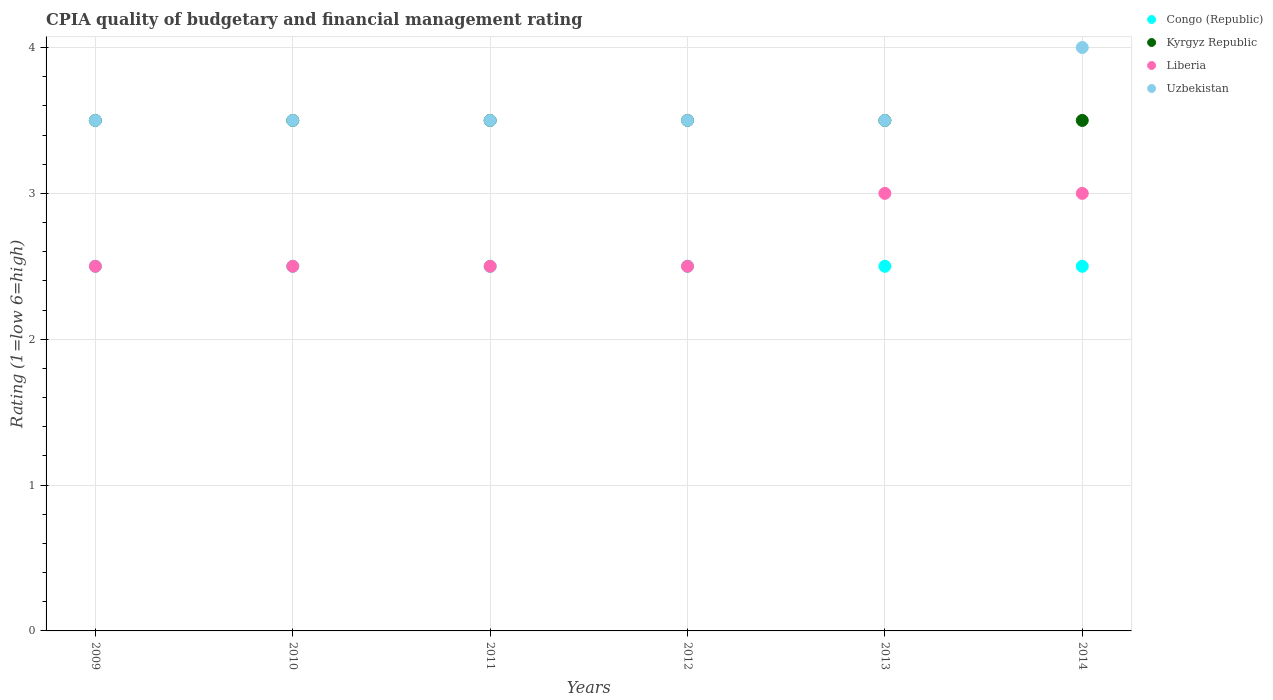In which year was the CPIA rating in Liberia minimum?
Give a very brief answer. 2009. What is the total CPIA rating in Kyrgyz Republic in the graph?
Your answer should be very brief. 21. What is the difference between the CPIA rating in Liberia in 2010 and the CPIA rating in Kyrgyz Republic in 2009?
Provide a short and direct response. -1. Is the CPIA rating in Kyrgyz Republic in 2012 less than that in 2013?
Give a very brief answer. No. Is the difference between the CPIA rating in Congo (Republic) in 2013 and 2014 greater than the difference between the CPIA rating in Kyrgyz Republic in 2013 and 2014?
Your response must be concise. No. What is the difference between the highest and the lowest CPIA rating in Kyrgyz Republic?
Provide a short and direct response. 0. In how many years, is the CPIA rating in Liberia greater than the average CPIA rating in Liberia taken over all years?
Ensure brevity in your answer.  2. Is the sum of the CPIA rating in Congo (Republic) in 2009 and 2011 greater than the maximum CPIA rating in Kyrgyz Republic across all years?
Offer a very short reply. Yes. Is it the case that in every year, the sum of the CPIA rating in Congo (Republic) and CPIA rating in Uzbekistan  is greater than the sum of CPIA rating in Kyrgyz Republic and CPIA rating in Liberia?
Provide a short and direct response. No. Does the CPIA rating in Uzbekistan monotonically increase over the years?
Your answer should be compact. No. Is the CPIA rating in Uzbekistan strictly less than the CPIA rating in Congo (Republic) over the years?
Make the answer very short. No. What is the difference between two consecutive major ticks on the Y-axis?
Give a very brief answer. 1. Are the values on the major ticks of Y-axis written in scientific E-notation?
Offer a very short reply. No. Does the graph contain any zero values?
Offer a very short reply. No. How many legend labels are there?
Make the answer very short. 4. What is the title of the graph?
Your answer should be very brief. CPIA quality of budgetary and financial management rating. Does "West Bank and Gaza" appear as one of the legend labels in the graph?
Provide a succinct answer. No. What is the Rating (1=low 6=high) in Congo (Republic) in 2009?
Make the answer very short. 2.5. What is the Rating (1=low 6=high) in Kyrgyz Republic in 2010?
Give a very brief answer. 3.5. What is the Rating (1=low 6=high) of Uzbekistan in 2010?
Provide a short and direct response. 3.5. What is the Rating (1=low 6=high) of Congo (Republic) in 2011?
Provide a short and direct response. 2.5. What is the Rating (1=low 6=high) in Kyrgyz Republic in 2011?
Give a very brief answer. 3.5. What is the Rating (1=low 6=high) in Uzbekistan in 2011?
Your answer should be very brief. 3.5. What is the Rating (1=low 6=high) of Congo (Republic) in 2012?
Keep it short and to the point. 2.5. What is the Rating (1=low 6=high) of Kyrgyz Republic in 2012?
Provide a succinct answer. 3.5. What is the Rating (1=low 6=high) in Liberia in 2012?
Your answer should be very brief. 2.5. What is the Rating (1=low 6=high) of Uzbekistan in 2012?
Offer a terse response. 3.5. What is the Rating (1=low 6=high) in Congo (Republic) in 2013?
Ensure brevity in your answer.  2.5. What is the Rating (1=low 6=high) in Liberia in 2013?
Your answer should be compact. 3. What is the Rating (1=low 6=high) in Kyrgyz Republic in 2014?
Ensure brevity in your answer.  3.5. Across all years, what is the maximum Rating (1=low 6=high) in Kyrgyz Republic?
Ensure brevity in your answer.  3.5. Across all years, what is the maximum Rating (1=low 6=high) in Liberia?
Your answer should be compact. 3. Across all years, what is the minimum Rating (1=low 6=high) in Liberia?
Offer a terse response. 2.5. What is the total Rating (1=low 6=high) in Liberia in the graph?
Give a very brief answer. 16. What is the difference between the Rating (1=low 6=high) of Kyrgyz Republic in 2009 and that in 2010?
Keep it short and to the point. 0. What is the difference between the Rating (1=low 6=high) of Uzbekistan in 2009 and that in 2010?
Offer a terse response. 0. What is the difference between the Rating (1=low 6=high) of Uzbekistan in 2009 and that in 2011?
Your answer should be very brief. 0. What is the difference between the Rating (1=low 6=high) of Uzbekistan in 2009 and that in 2012?
Your answer should be compact. 0. What is the difference between the Rating (1=low 6=high) in Congo (Republic) in 2009 and that in 2013?
Your response must be concise. 0. What is the difference between the Rating (1=low 6=high) of Uzbekistan in 2009 and that in 2013?
Provide a succinct answer. 0. What is the difference between the Rating (1=low 6=high) of Kyrgyz Republic in 2009 and that in 2014?
Your answer should be very brief. 0. What is the difference between the Rating (1=low 6=high) of Liberia in 2009 and that in 2014?
Offer a very short reply. -0.5. What is the difference between the Rating (1=low 6=high) in Uzbekistan in 2009 and that in 2014?
Your response must be concise. -0.5. What is the difference between the Rating (1=low 6=high) of Congo (Republic) in 2010 and that in 2011?
Make the answer very short. 0. What is the difference between the Rating (1=low 6=high) in Kyrgyz Republic in 2010 and that in 2011?
Your response must be concise. 0. What is the difference between the Rating (1=low 6=high) of Liberia in 2010 and that in 2011?
Your response must be concise. 0. What is the difference between the Rating (1=low 6=high) in Kyrgyz Republic in 2010 and that in 2012?
Provide a succinct answer. 0. What is the difference between the Rating (1=low 6=high) in Liberia in 2010 and that in 2012?
Keep it short and to the point. 0. What is the difference between the Rating (1=low 6=high) in Congo (Republic) in 2010 and that in 2013?
Provide a short and direct response. 0. What is the difference between the Rating (1=low 6=high) in Liberia in 2010 and that in 2013?
Offer a terse response. -0.5. What is the difference between the Rating (1=low 6=high) of Kyrgyz Republic in 2010 and that in 2014?
Your answer should be very brief. 0. What is the difference between the Rating (1=low 6=high) of Uzbekistan in 2010 and that in 2014?
Offer a very short reply. -0.5. What is the difference between the Rating (1=low 6=high) of Congo (Republic) in 2011 and that in 2012?
Ensure brevity in your answer.  0. What is the difference between the Rating (1=low 6=high) of Kyrgyz Republic in 2011 and that in 2012?
Give a very brief answer. 0. What is the difference between the Rating (1=low 6=high) of Liberia in 2011 and that in 2012?
Offer a terse response. 0. What is the difference between the Rating (1=low 6=high) in Uzbekistan in 2011 and that in 2013?
Provide a short and direct response. 0. What is the difference between the Rating (1=low 6=high) of Liberia in 2011 and that in 2014?
Give a very brief answer. -0.5. What is the difference between the Rating (1=low 6=high) of Kyrgyz Republic in 2012 and that in 2013?
Offer a terse response. 0. What is the difference between the Rating (1=low 6=high) of Uzbekistan in 2012 and that in 2013?
Provide a short and direct response. 0. What is the difference between the Rating (1=low 6=high) of Congo (Republic) in 2012 and that in 2014?
Provide a succinct answer. 0. What is the difference between the Rating (1=low 6=high) in Uzbekistan in 2012 and that in 2014?
Make the answer very short. -0.5. What is the difference between the Rating (1=low 6=high) in Congo (Republic) in 2013 and that in 2014?
Your answer should be very brief. 0. What is the difference between the Rating (1=low 6=high) of Liberia in 2013 and that in 2014?
Offer a very short reply. 0. What is the difference between the Rating (1=low 6=high) in Congo (Republic) in 2009 and the Rating (1=low 6=high) in Kyrgyz Republic in 2010?
Provide a succinct answer. -1. What is the difference between the Rating (1=low 6=high) in Congo (Republic) in 2009 and the Rating (1=low 6=high) in Uzbekistan in 2010?
Ensure brevity in your answer.  -1. What is the difference between the Rating (1=low 6=high) in Kyrgyz Republic in 2009 and the Rating (1=low 6=high) in Liberia in 2010?
Provide a succinct answer. 1. What is the difference between the Rating (1=low 6=high) in Liberia in 2009 and the Rating (1=low 6=high) in Uzbekistan in 2010?
Your answer should be very brief. -1. What is the difference between the Rating (1=low 6=high) of Congo (Republic) in 2009 and the Rating (1=low 6=high) of Uzbekistan in 2011?
Offer a very short reply. -1. What is the difference between the Rating (1=low 6=high) of Kyrgyz Republic in 2009 and the Rating (1=low 6=high) of Uzbekistan in 2011?
Offer a terse response. 0. What is the difference between the Rating (1=low 6=high) in Congo (Republic) in 2009 and the Rating (1=low 6=high) in Kyrgyz Republic in 2012?
Provide a succinct answer. -1. What is the difference between the Rating (1=low 6=high) of Congo (Republic) in 2009 and the Rating (1=low 6=high) of Liberia in 2012?
Provide a succinct answer. 0. What is the difference between the Rating (1=low 6=high) of Congo (Republic) in 2009 and the Rating (1=low 6=high) of Uzbekistan in 2012?
Provide a short and direct response. -1. What is the difference between the Rating (1=low 6=high) of Congo (Republic) in 2009 and the Rating (1=low 6=high) of Kyrgyz Republic in 2013?
Offer a very short reply. -1. What is the difference between the Rating (1=low 6=high) of Congo (Republic) in 2009 and the Rating (1=low 6=high) of Liberia in 2013?
Your answer should be very brief. -0.5. What is the difference between the Rating (1=low 6=high) in Congo (Republic) in 2009 and the Rating (1=low 6=high) in Uzbekistan in 2013?
Your response must be concise. -1. What is the difference between the Rating (1=low 6=high) of Kyrgyz Republic in 2009 and the Rating (1=low 6=high) of Liberia in 2013?
Offer a very short reply. 0.5. What is the difference between the Rating (1=low 6=high) in Liberia in 2009 and the Rating (1=low 6=high) in Uzbekistan in 2013?
Make the answer very short. -1. What is the difference between the Rating (1=low 6=high) in Congo (Republic) in 2009 and the Rating (1=low 6=high) in Kyrgyz Republic in 2014?
Your response must be concise. -1. What is the difference between the Rating (1=low 6=high) in Congo (Republic) in 2009 and the Rating (1=low 6=high) in Liberia in 2014?
Ensure brevity in your answer.  -0.5. What is the difference between the Rating (1=low 6=high) in Congo (Republic) in 2009 and the Rating (1=low 6=high) in Uzbekistan in 2014?
Offer a very short reply. -1.5. What is the difference between the Rating (1=low 6=high) in Kyrgyz Republic in 2009 and the Rating (1=low 6=high) in Uzbekistan in 2014?
Provide a succinct answer. -0.5. What is the difference between the Rating (1=low 6=high) in Congo (Republic) in 2010 and the Rating (1=low 6=high) in Kyrgyz Republic in 2011?
Make the answer very short. -1. What is the difference between the Rating (1=low 6=high) of Kyrgyz Republic in 2010 and the Rating (1=low 6=high) of Liberia in 2011?
Provide a short and direct response. 1. What is the difference between the Rating (1=low 6=high) in Kyrgyz Republic in 2010 and the Rating (1=low 6=high) in Uzbekistan in 2011?
Keep it short and to the point. 0. What is the difference between the Rating (1=low 6=high) in Liberia in 2010 and the Rating (1=low 6=high) in Uzbekistan in 2011?
Your answer should be very brief. -1. What is the difference between the Rating (1=low 6=high) in Congo (Republic) in 2010 and the Rating (1=low 6=high) in Kyrgyz Republic in 2012?
Provide a succinct answer. -1. What is the difference between the Rating (1=low 6=high) in Congo (Republic) in 2010 and the Rating (1=low 6=high) in Liberia in 2012?
Provide a short and direct response. 0. What is the difference between the Rating (1=low 6=high) in Congo (Republic) in 2010 and the Rating (1=low 6=high) in Uzbekistan in 2012?
Provide a short and direct response. -1. What is the difference between the Rating (1=low 6=high) of Kyrgyz Republic in 2010 and the Rating (1=low 6=high) of Liberia in 2012?
Offer a terse response. 1. What is the difference between the Rating (1=low 6=high) of Kyrgyz Republic in 2010 and the Rating (1=low 6=high) of Uzbekistan in 2012?
Make the answer very short. 0. What is the difference between the Rating (1=low 6=high) in Congo (Republic) in 2010 and the Rating (1=low 6=high) in Kyrgyz Republic in 2013?
Provide a short and direct response. -1. What is the difference between the Rating (1=low 6=high) in Congo (Republic) in 2010 and the Rating (1=low 6=high) in Liberia in 2013?
Your answer should be very brief. -0.5. What is the difference between the Rating (1=low 6=high) of Congo (Republic) in 2010 and the Rating (1=low 6=high) of Uzbekistan in 2013?
Offer a terse response. -1. What is the difference between the Rating (1=low 6=high) in Kyrgyz Republic in 2010 and the Rating (1=low 6=high) in Liberia in 2013?
Your answer should be compact. 0.5. What is the difference between the Rating (1=low 6=high) in Congo (Republic) in 2010 and the Rating (1=low 6=high) in Kyrgyz Republic in 2014?
Offer a very short reply. -1. What is the difference between the Rating (1=low 6=high) in Congo (Republic) in 2010 and the Rating (1=low 6=high) in Liberia in 2014?
Provide a short and direct response. -0.5. What is the difference between the Rating (1=low 6=high) of Kyrgyz Republic in 2010 and the Rating (1=low 6=high) of Liberia in 2014?
Ensure brevity in your answer.  0.5. What is the difference between the Rating (1=low 6=high) in Kyrgyz Republic in 2010 and the Rating (1=low 6=high) in Uzbekistan in 2014?
Give a very brief answer. -0.5. What is the difference between the Rating (1=low 6=high) in Liberia in 2010 and the Rating (1=low 6=high) in Uzbekistan in 2014?
Your answer should be very brief. -1.5. What is the difference between the Rating (1=low 6=high) of Congo (Republic) in 2011 and the Rating (1=low 6=high) of Kyrgyz Republic in 2012?
Your response must be concise. -1. What is the difference between the Rating (1=low 6=high) of Congo (Republic) in 2011 and the Rating (1=low 6=high) of Liberia in 2012?
Offer a terse response. 0. What is the difference between the Rating (1=low 6=high) of Kyrgyz Republic in 2011 and the Rating (1=low 6=high) of Uzbekistan in 2012?
Ensure brevity in your answer.  0. What is the difference between the Rating (1=low 6=high) of Liberia in 2011 and the Rating (1=low 6=high) of Uzbekistan in 2012?
Make the answer very short. -1. What is the difference between the Rating (1=low 6=high) in Congo (Republic) in 2011 and the Rating (1=low 6=high) in Kyrgyz Republic in 2013?
Offer a terse response. -1. What is the difference between the Rating (1=low 6=high) of Congo (Republic) in 2011 and the Rating (1=low 6=high) of Liberia in 2013?
Keep it short and to the point. -0.5. What is the difference between the Rating (1=low 6=high) of Kyrgyz Republic in 2011 and the Rating (1=low 6=high) of Uzbekistan in 2013?
Make the answer very short. 0. What is the difference between the Rating (1=low 6=high) of Liberia in 2011 and the Rating (1=low 6=high) of Uzbekistan in 2013?
Ensure brevity in your answer.  -1. What is the difference between the Rating (1=low 6=high) in Congo (Republic) in 2011 and the Rating (1=low 6=high) in Liberia in 2014?
Make the answer very short. -0.5. What is the difference between the Rating (1=low 6=high) in Kyrgyz Republic in 2011 and the Rating (1=low 6=high) in Liberia in 2014?
Ensure brevity in your answer.  0.5. What is the difference between the Rating (1=low 6=high) of Kyrgyz Republic in 2011 and the Rating (1=low 6=high) of Uzbekistan in 2014?
Provide a succinct answer. -0.5. What is the difference between the Rating (1=low 6=high) of Liberia in 2011 and the Rating (1=low 6=high) of Uzbekistan in 2014?
Your answer should be very brief. -1.5. What is the difference between the Rating (1=low 6=high) of Congo (Republic) in 2012 and the Rating (1=low 6=high) of Kyrgyz Republic in 2013?
Your answer should be very brief. -1. What is the difference between the Rating (1=low 6=high) of Congo (Republic) in 2012 and the Rating (1=low 6=high) of Liberia in 2013?
Offer a terse response. -0.5. What is the difference between the Rating (1=low 6=high) in Kyrgyz Republic in 2012 and the Rating (1=low 6=high) in Liberia in 2013?
Keep it short and to the point. 0.5. What is the difference between the Rating (1=low 6=high) of Liberia in 2012 and the Rating (1=low 6=high) of Uzbekistan in 2013?
Ensure brevity in your answer.  -1. What is the difference between the Rating (1=low 6=high) in Congo (Republic) in 2012 and the Rating (1=low 6=high) in Kyrgyz Republic in 2014?
Offer a terse response. -1. What is the difference between the Rating (1=low 6=high) in Congo (Republic) in 2012 and the Rating (1=low 6=high) in Uzbekistan in 2014?
Your answer should be very brief. -1.5. What is the difference between the Rating (1=low 6=high) of Kyrgyz Republic in 2012 and the Rating (1=low 6=high) of Uzbekistan in 2014?
Your answer should be compact. -0.5. What is the difference between the Rating (1=low 6=high) of Congo (Republic) in 2013 and the Rating (1=low 6=high) of Kyrgyz Republic in 2014?
Your response must be concise. -1. What is the difference between the Rating (1=low 6=high) in Congo (Republic) in 2013 and the Rating (1=low 6=high) in Liberia in 2014?
Make the answer very short. -0.5. What is the difference between the Rating (1=low 6=high) in Congo (Republic) in 2013 and the Rating (1=low 6=high) in Uzbekistan in 2014?
Keep it short and to the point. -1.5. What is the difference between the Rating (1=low 6=high) of Kyrgyz Republic in 2013 and the Rating (1=low 6=high) of Liberia in 2014?
Your answer should be compact. 0.5. What is the difference between the Rating (1=low 6=high) of Liberia in 2013 and the Rating (1=low 6=high) of Uzbekistan in 2014?
Your answer should be compact. -1. What is the average Rating (1=low 6=high) of Congo (Republic) per year?
Your response must be concise. 2.5. What is the average Rating (1=low 6=high) of Kyrgyz Republic per year?
Your response must be concise. 3.5. What is the average Rating (1=low 6=high) of Liberia per year?
Provide a short and direct response. 2.67. What is the average Rating (1=low 6=high) of Uzbekistan per year?
Your answer should be very brief. 3.58. In the year 2009, what is the difference between the Rating (1=low 6=high) of Congo (Republic) and Rating (1=low 6=high) of Uzbekistan?
Provide a succinct answer. -1. In the year 2009, what is the difference between the Rating (1=low 6=high) of Kyrgyz Republic and Rating (1=low 6=high) of Uzbekistan?
Make the answer very short. 0. In the year 2009, what is the difference between the Rating (1=low 6=high) in Liberia and Rating (1=low 6=high) in Uzbekistan?
Offer a terse response. -1. In the year 2010, what is the difference between the Rating (1=low 6=high) of Congo (Republic) and Rating (1=low 6=high) of Liberia?
Provide a succinct answer. 0. In the year 2010, what is the difference between the Rating (1=low 6=high) in Kyrgyz Republic and Rating (1=low 6=high) in Liberia?
Offer a very short reply. 1. In the year 2010, what is the difference between the Rating (1=low 6=high) of Kyrgyz Republic and Rating (1=low 6=high) of Uzbekistan?
Ensure brevity in your answer.  0. In the year 2011, what is the difference between the Rating (1=low 6=high) of Congo (Republic) and Rating (1=low 6=high) of Liberia?
Provide a succinct answer. 0. In the year 2011, what is the difference between the Rating (1=low 6=high) of Congo (Republic) and Rating (1=low 6=high) of Uzbekistan?
Provide a succinct answer. -1. In the year 2011, what is the difference between the Rating (1=low 6=high) in Kyrgyz Republic and Rating (1=low 6=high) in Liberia?
Your answer should be compact. 1. In the year 2011, what is the difference between the Rating (1=low 6=high) in Kyrgyz Republic and Rating (1=low 6=high) in Uzbekistan?
Give a very brief answer. 0. In the year 2012, what is the difference between the Rating (1=low 6=high) of Congo (Republic) and Rating (1=low 6=high) of Liberia?
Your answer should be compact. 0. In the year 2012, what is the difference between the Rating (1=low 6=high) of Kyrgyz Republic and Rating (1=low 6=high) of Uzbekistan?
Offer a very short reply. 0. In the year 2013, what is the difference between the Rating (1=low 6=high) in Congo (Republic) and Rating (1=low 6=high) in Kyrgyz Republic?
Provide a succinct answer. -1. In the year 2013, what is the difference between the Rating (1=low 6=high) in Congo (Republic) and Rating (1=low 6=high) in Liberia?
Ensure brevity in your answer.  -0.5. In the year 2013, what is the difference between the Rating (1=low 6=high) in Kyrgyz Republic and Rating (1=low 6=high) in Uzbekistan?
Offer a very short reply. 0. In the year 2013, what is the difference between the Rating (1=low 6=high) of Liberia and Rating (1=low 6=high) of Uzbekistan?
Your answer should be very brief. -0.5. In the year 2014, what is the difference between the Rating (1=low 6=high) in Congo (Republic) and Rating (1=low 6=high) in Kyrgyz Republic?
Make the answer very short. -1. In the year 2014, what is the difference between the Rating (1=low 6=high) in Congo (Republic) and Rating (1=low 6=high) in Liberia?
Provide a short and direct response. -0.5. In the year 2014, what is the difference between the Rating (1=low 6=high) in Kyrgyz Republic and Rating (1=low 6=high) in Liberia?
Give a very brief answer. 0.5. In the year 2014, what is the difference between the Rating (1=low 6=high) of Liberia and Rating (1=low 6=high) of Uzbekistan?
Offer a terse response. -1. What is the ratio of the Rating (1=low 6=high) of Congo (Republic) in 2009 to that in 2011?
Provide a succinct answer. 1. What is the ratio of the Rating (1=low 6=high) in Kyrgyz Republic in 2009 to that in 2011?
Offer a terse response. 1. What is the ratio of the Rating (1=low 6=high) of Liberia in 2009 to that in 2011?
Give a very brief answer. 1. What is the ratio of the Rating (1=low 6=high) in Congo (Republic) in 2009 to that in 2012?
Provide a short and direct response. 1. What is the ratio of the Rating (1=low 6=high) of Liberia in 2009 to that in 2012?
Your answer should be compact. 1. What is the ratio of the Rating (1=low 6=high) of Congo (Republic) in 2009 to that in 2013?
Ensure brevity in your answer.  1. What is the ratio of the Rating (1=low 6=high) of Kyrgyz Republic in 2009 to that in 2013?
Keep it short and to the point. 1. What is the ratio of the Rating (1=low 6=high) of Uzbekistan in 2009 to that in 2013?
Give a very brief answer. 1. What is the ratio of the Rating (1=low 6=high) of Congo (Republic) in 2009 to that in 2014?
Your answer should be very brief. 1. What is the ratio of the Rating (1=low 6=high) of Kyrgyz Republic in 2009 to that in 2014?
Your answer should be compact. 1. What is the ratio of the Rating (1=low 6=high) of Liberia in 2009 to that in 2014?
Offer a very short reply. 0.83. What is the ratio of the Rating (1=low 6=high) of Uzbekistan in 2009 to that in 2014?
Your response must be concise. 0.88. What is the ratio of the Rating (1=low 6=high) in Congo (Republic) in 2010 to that in 2011?
Your answer should be compact. 1. What is the ratio of the Rating (1=low 6=high) of Liberia in 2010 to that in 2011?
Your response must be concise. 1. What is the ratio of the Rating (1=low 6=high) of Kyrgyz Republic in 2010 to that in 2012?
Offer a terse response. 1. What is the ratio of the Rating (1=low 6=high) in Liberia in 2010 to that in 2012?
Your response must be concise. 1. What is the ratio of the Rating (1=low 6=high) in Kyrgyz Republic in 2010 to that in 2013?
Your answer should be compact. 1. What is the ratio of the Rating (1=low 6=high) in Liberia in 2010 to that in 2013?
Offer a very short reply. 0.83. What is the ratio of the Rating (1=low 6=high) of Congo (Republic) in 2010 to that in 2014?
Keep it short and to the point. 1. What is the ratio of the Rating (1=low 6=high) in Liberia in 2010 to that in 2014?
Keep it short and to the point. 0.83. What is the ratio of the Rating (1=low 6=high) in Uzbekistan in 2010 to that in 2014?
Provide a succinct answer. 0.88. What is the ratio of the Rating (1=low 6=high) of Congo (Republic) in 2011 to that in 2012?
Offer a very short reply. 1. What is the ratio of the Rating (1=low 6=high) in Congo (Republic) in 2011 to that in 2013?
Ensure brevity in your answer.  1. What is the ratio of the Rating (1=low 6=high) in Liberia in 2011 to that in 2013?
Your answer should be compact. 0.83. What is the ratio of the Rating (1=low 6=high) of Uzbekistan in 2011 to that in 2013?
Offer a very short reply. 1. What is the ratio of the Rating (1=low 6=high) in Congo (Republic) in 2012 to that in 2013?
Your response must be concise. 1. What is the ratio of the Rating (1=low 6=high) of Kyrgyz Republic in 2012 to that in 2013?
Provide a succinct answer. 1. What is the ratio of the Rating (1=low 6=high) in Liberia in 2012 to that in 2013?
Offer a very short reply. 0.83. What is the ratio of the Rating (1=low 6=high) in Uzbekistan in 2012 to that in 2013?
Give a very brief answer. 1. What is the ratio of the Rating (1=low 6=high) in Congo (Republic) in 2012 to that in 2014?
Offer a terse response. 1. What is the ratio of the Rating (1=low 6=high) in Kyrgyz Republic in 2012 to that in 2014?
Your response must be concise. 1. What is the ratio of the Rating (1=low 6=high) in Liberia in 2012 to that in 2014?
Your answer should be very brief. 0.83. What is the ratio of the Rating (1=low 6=high) of Uzbekistan in 2012 to that in 2014?
Offer a terse response. 0.88. What is the ratio of the Rating (1=low 6=high) in Congo (Republic) in 2013 to that in 2014?
Your answer should be compact. 1. What is the difference between the highest and the second highest Rating (1=low 6=high) in Kyrgyz Republic?
Keep it short and to the point. 0. What is the difference between the highest and the second highest Rating (1=low 6=high) in Liberia?
Give a very brief answer. 0. What is the difference between the highest and the second highest Rating (1=low 6=high) in Uzbekistan?
Offer a terse response. 0.5. What is the difference between the highest and the lowest Rating (1=low 6=high) of Congo (Republic)?
Give a very brief answer. 0. What is the difference between the highest and the lowest Rating (1=low 6=high) of Liberia?
Keep it short and to the point. 0.5. What is the difference between the highest and the lowest Rating (1=low 6=high) in Uzbekistan?
Provide a short and direct response. 0.5. 